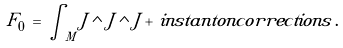Convert formula to latex. <formula><loc_0><loc_0><loc_500><loc_500>F _ { 0 } \, = \, \int _ { M } J \wedge J \wedge J + \, i n s t a n t o n c o r r e c t i o n s \, .</formula> 